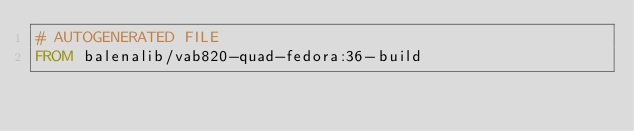<code> <loc_0><loc_0><loc_500><loc_500><_Dockerfile_># AUTOGENERATED FILE
FROM balenalib/vab820-quad-fedora:36-build
</code> 